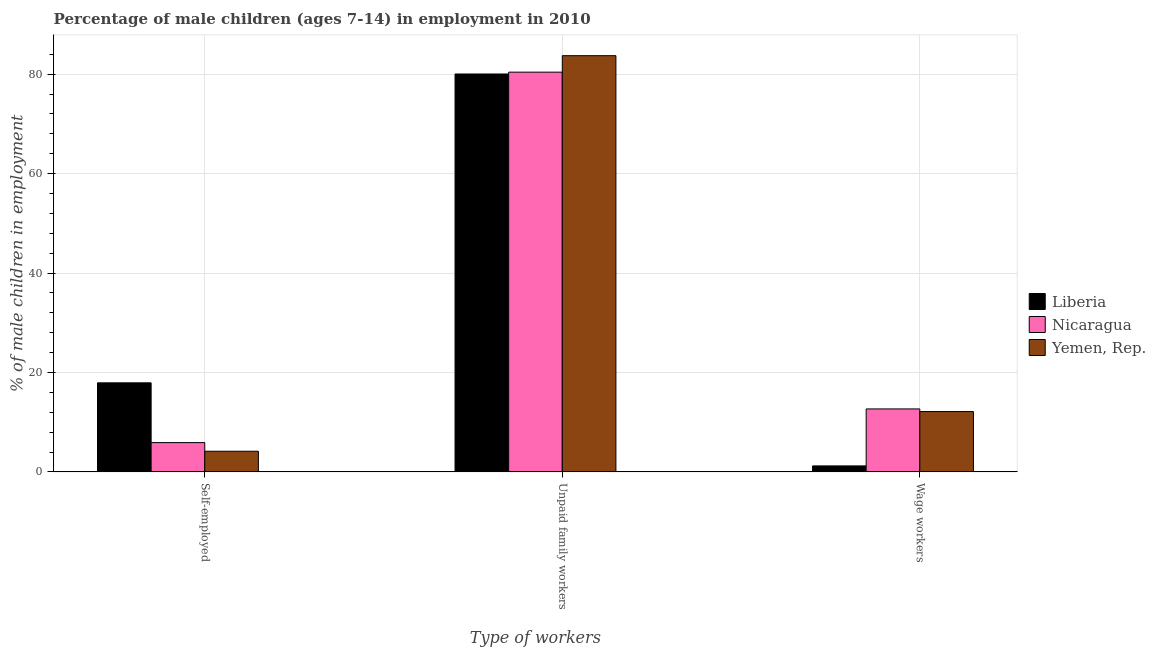Are the number of bars per tick equal to the number of legend labels?
Your response must be concise. Yes. How many bars are there on the 3rd tick from the left?
Offer a very short reply. 3. How many bars are there on the 3rd tick from the right?
Your answer should be very brief. 3. What is the label of the 2nd group of bars from the left?
Offer a terse response. Unpaid family workers. What is the percentage of children employed as wage workers in Nicaragua?
Your response must be concise. 12.67. Across all countries, what is the maximum percentage of self employed children?
Your response must be concise. 17.92. Across all countries, what is the minimum percentage of children employed as unpaid family workers?
Your answer should be very brief. 80.03. In which country was the percentage of children employed as wage workers maximum?
Give a very brief answer. Nicaragua. In which country was the percentage of children employed as wage workers minimum?
Give a very brief answer. Liberia. What is the total percentage of children employed as wage workers in the graph?
Provide a succinct answer. 26.02. What is the difference between the percentage of children employed as unpaid family workers in Yemen, Rep. and that in Liberia?
Ensure brevity in your answer.  3.68. What is the difference between the percentage of children employed as unpaid family workers in Yemen, Rep. and the percentage of children employed as wage workers in Nicaragua?
Offer a terse response. 71.04. What is the average percentage of children employed as unpaid family workers per country?
Your answer should be very brief. 81.38. What is the difference between the percentage of children employed as wage workers and percentage of children employed as unpaid family workers in Nicaragua?
Your answer should be very brief. -67.73. In how many countries, is the percentage of self employed children greater than 36 %?
Your response must be concise. 0. What is the ratio of the percentage of children employed as unpaid family workers in Nicaragua to that in Liberia?
Give a very brief answer. 1. Is the percentage of self employed children in Yemen, Rep. less than that in Nicaragua?
Your answer should be compact. Yes. What is the difference between the highest and the second highest percentage of children employed as wage workers?
Offer a terse response. 0.53. What is the difference between the highest and the lowest percentage of children employed as wage workers?
Offer a very short reply. 11.46. What does the 1st bar from the left in Wage workers represents?
Offer a very short reply. Liberia. What does the 2nd bar from the right in Unpaid family workers represents?
Offer a very short reply. Nicaragua. Are all the bars in the graph horizontal?
Keep it short and to the point. No. Does the graph contain any zero values?
Offer a terse response. No. Does the graph contain grids?
Make the answer very short. Yes. Where does the legend appear in the graph?
Give a very brief answer. Center right. How are the legend labels stacked?
Your response must be concise. Vertical. What is the title of the graph?
Your response must be concise. Percentage of male children (ages 7-14) in employment in 2010. What is the label or title of the X-axis?
Give a very brief answer. Type of workers. What is the label or title of the Y-axis?
Keep it short and to the point. % of male children in employment. What is the % of male children in employment in Liberia in Self-employed?
Provide a short and direct response. 17.92. What is the % of male children in employment in Nicaragua in Self-employed?
Offer a terse response. 5.9. What is the % of male children in employment in Yemen, Rep. in Self-employed?
Your answer should be very brief. 4.16. What is the % of male children in employment of Liberia in Unpaid family workers?
Offer a very short reply. 80.03. What is the % of male children in employment in Nicaragua in Unpaid family workers?
Provide a short and direct response. 80.4. What is the % of male children in employment in Yemen, Rep. in Unpaid family workers?
Your answer should be compact. 83.71. What is the % of male children in employment of Liberia in Wage workers?
Offer a very short reply. 1.21. What is the % of male children in employment of Nicaragua in Wage workers?
Offer a terse response. 12.67. What is the % of male children in employment in Yemen, Rep. in Wage workers?
Your answer should be very brief. 12.14. Across all Type of workers, what is the maximum % of male children in employment in Liberia?
Provide a succinct answer. 80.03. Across all Type of workers, what is the maximum % of male children in employment in Nicaragua?
Provide a succinct answer. 80.4. Across all Type of workers, what is the maximum % of male children in employment in Yemen, Rep.?
Offer a terse response. 83.71. Across all Type of workers, what is the minimum % of male children in employment of Liberia?
Keep it short and to the point. 1.21. Across all Type of workers, what is the minimum % of male children in employment of Nicaragua?
Your answer should be very brief. 5.9. Across all Type of workers, what is the minimum % of male children in employment in Yemen, Rep.?
Ensure brevity in your answer.  4.16. What is the total % of male children in employment of Liberia in the graph?
Provide a short and direct response. 99.16. What is the total % of male children in employment of Nicaragua in the graph?
Keep it short and to the point. 98.97. What is the total % of male children in employment of Yemen, Rep. in the graph?
Ensure brevity in your answer.  100.01. What is the difference between the % of male children in employment of Liberia in Self-employed and that in Unpaid family workers?
Make the answer very short. -62.11. What is the difference between the % of male children in employment of Nicaragua in Self-employed and that in Unpaid family workers?
Offer a terse response. -74.5. What is the difference between the % of male children in employment of Yemen, Rep. in Self-employed and that in Unpaid family workers?
Your answer should be compact. -79.55. What is the difference between the % of male children in employment in Liberia in Self-employed and that in Wage workers?
Your response must be concise. 16.71. What is the difference between the % of male children in employment in Nicaragua in Self-employed and that in Wage workers?
Ensure brevity in your answer.  -6.77. What is the difference between the % of male children in employment in Yemen, Rep. in Self-employed and that in Wage workers?
Keep it short and to the point. -7.98. What is the difference between the % of male children in employment in Liberia in Unpaid family workers and that in Wage workers?
Offer a very short reply. 78.82. What is the difference between the % of male children in employment of Nicaragua in Unpaid family workers and that in Wage workers?
Your answer should be compact. 67.73. What is the difference between the % of male children in employment of Yemen, Rep. in Unpaid family workers and that in Wage workers?
Make the answer very short. 71.57. What is the difference between the % of male children in employment in Liberia in Self-employed and the % of male children in employment in Nicaragua in Unpaid family workers?
Provide a short and direct response. -62.48. What is the difference between the % of male children in employment in Liberia in Self-employed and the % of male children in employment in Yemen, Rep. in Unpaid family workers?
Your response must be concise. -65.79. What is the difference between the % of male children in employment of Nicaragua in Self-employed and the % of male children in employment of Yemen, Rep. in Unpaid family workers?
Your answer should be compact. -77.81. What is the difference between the % of male children in employment in Liberia in Self-employed and the % of male children in employment in Nicaragua in Wage workers?
Keep it short and to the point. 5.25. What is the difference between the % of male children in employment in Liberia in Self-employed and the % of male children in employment in Yemen, Rep. in Wage workers?
Offer a terse response. 5.78. What is the difference between the % of male children in employment of Nicaragua in Self-employed and the % of male children in employment of Yemen, Rep. in Wage workers?
Your answer should be very brief. -6.24. What is the difference between the % of male children in employment of Liberia in Unpaid family workers and the % of male children in employment of Nicaragua in Wage workers?
Offer a terse response. 67.36. What is the difference between the % of male children in employment of Liberia in Unpaid family workers and the % of male children in employment of Yemen, Rep. in Wage workers?
Make the answer very short. 67.89. What is the difference between the % of male children in employment of Nicaragua in Unpaid family workers and the % of male children in employment of Yemen, Rep. in Wage workers?
Provide a short and direct response. 68.26. What is the average % of male children in employment of Liberia per Type of workers?
Ensure brevity in your answer.  33.05. What is the average % of male children in employment in Nicaragua per Type of workers?
Provide a short and direct response. 32.99. What is the average % of male children in employment of Yemen, Rep. per Type of workers?
Keep it short and to the point. 33.34. What is the difference between the % of male children in employment in Liberia and % of male children in employment in Nicaragua in Self-employed?
Your answer should be very brief. 12.02. What is the difference between the % of male children in employment in Liberia and % of male children in employment in Yemen, Rep. in Self-employed?
Make the answer very short. 13.76. What is the difference between the % of male children in employment of Nicaragua and % of male children in employment of Yemen, Rep. in Self-employed?
Keep it short and to the point. 1.74. What is the difference between the % of male children in employment of Liberia and % of male children in employment of Nicaragua in Unpaid family workers?
Your answer should be very brief. -0.37. What is the difference between the % of male children in employment of Liberia and % of male children in employment of Yemen, Rep. in Unpaid family workers?
Provide a short and direct response. -3.68. What is the difference between the % of male children in employment of Nicaragua and % of male children in employment of Yemen, Rep. in Unpaid family workers?
Ensure brevity in your answer.  -3.31. What is the difference between the % of male children in employment of Liberia and % of male children in employment of Nicaragua in Wage workers?
Ensure brevity in your answer.  -11.46. What is the difference between the % of male children in employment of Liberia and % of male children in employment of Yemen, Rep. in Wage workers?
Provide a succinct answer. -10.93. What is the difference between the % of male children in employment in Nicaragua and % of male children in employment in Yemen, Rep. in Wage workers?
Keep it short and to the point. 0.53. What is the ratio of the % of male children in employment of Liberia in Self-employed to that in Unpaid family workers?
Ensure brevity in your answer.  0.22. What is the ratio of the % of male children in employment in Nicaragua in Self-employed to that in Unpaid family workers?
Make the answer very short. 0.07. What is the ratio of the % of male children in employment of Yemen, Rep. in Self-employed to that in Unpaid family workers?
Offer a terse response. 0.05. What is the ratio of the % of male children in employment in Liberia in Self-employed to that in Wage workers?
Your response must be concise. 14.81. What is the ratio of the % of male children in employment in Nicaragua in Self-employed to that in Wage workers?
Offer a very short reply. 0.47. What is the ratio of the % of male children in employment in Yemen, Rep. in Self-employed to that in Wage workers?
Your answer should be very brief. 0.34. What is the ratio of the % of male children in employment in Liberia in Unpaid family workers to that in Wage workers?
Your response must be concise. 66.14. What is the ratio of the % of male children in employment of Nicaragua in Unpaid family workers to that in Wage workers?
Provide a succinct answer. 6.35. What is the ratio of the % of male children in employment of Yemen, Rep. in Unpaid family workers to that in Wage workers?
Provide a succinct answer. 6.9. What is the difference between the highest and the second highest % of male children in employment of Liberia?
Give a very brief answer. 62.11. What is the difference between the highest and the second highest % of male children in employment of Nicaragua?
Provide a short and direct response. 67.73. What is the difference between the highest and the second highest % of male children in employment of Yemen, Rep.?
Give a very brief answer. 71.57. What is the difference between the highest and the lowest % of male children in employment in Liberia?
Your answer should be compact. 78.82. What is the difference between the highest and the lowest % of male children in employment of Nicaragua?
Keep it short and to the point. 74.5. What is the difference between the highest and the lowest % of male children in employment of Yemen, Rep.?
Your answer should be very brief. 79.55. 